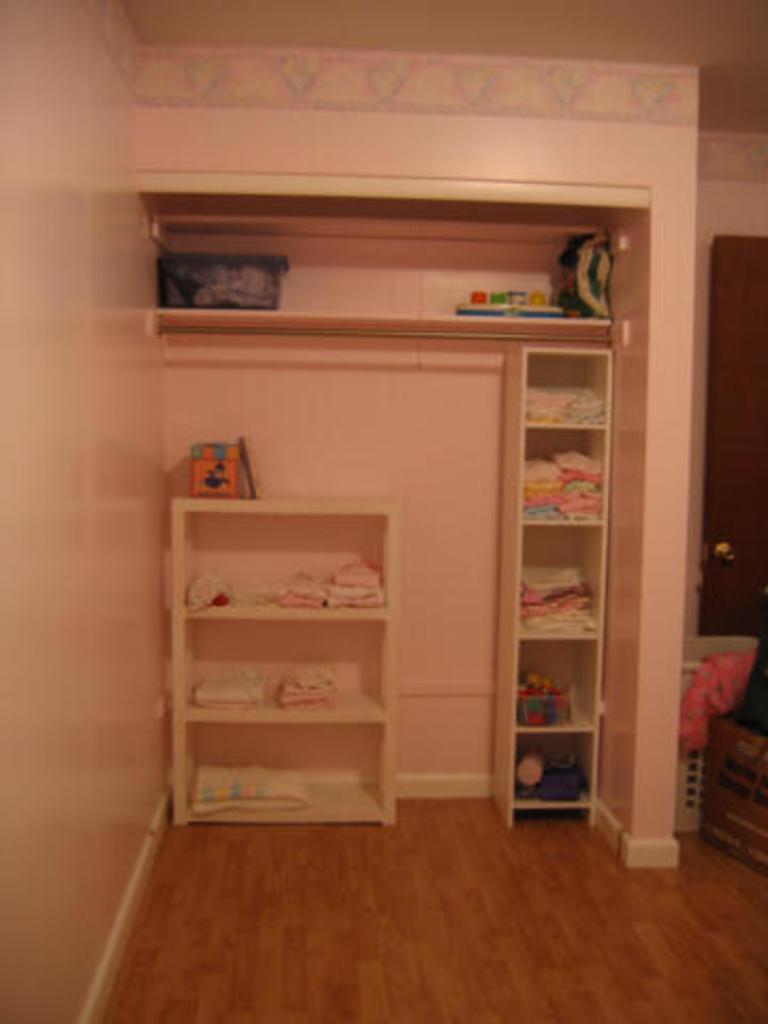Describe this image in one or two sentences. In this image we can see some shelves in which there are some clothes and there is door. 